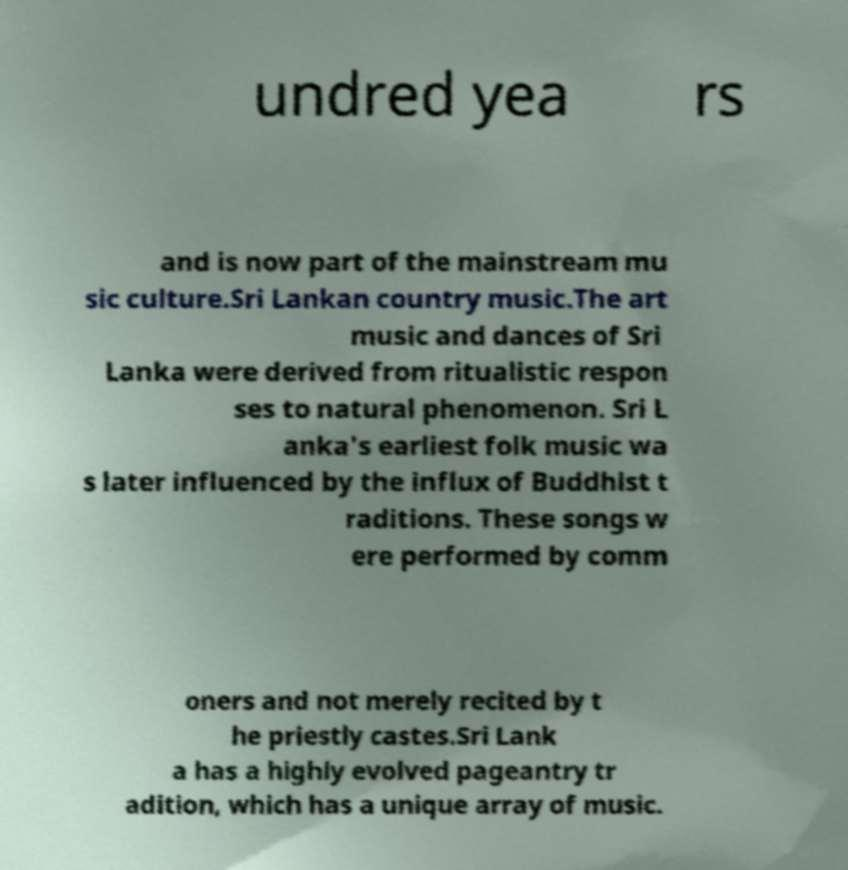Could you assist in decoding the text presented in this image and type it out clearly? undred yea rs and is now part of the mainstream mu sic culture.Sri Lankan country music.The art music and dances of Sri Lanka were derived from ritualistic respon ses to natural phenomenon. Sri L anka's earliest folk music wa s later influenced by the influx of Buddhist t raditions. These songs w ere performed by comm oners and not merely recited by t he priestly castes.Sri Lank a has a highly evolved pageantry tr adition, which has a unique array of music. 